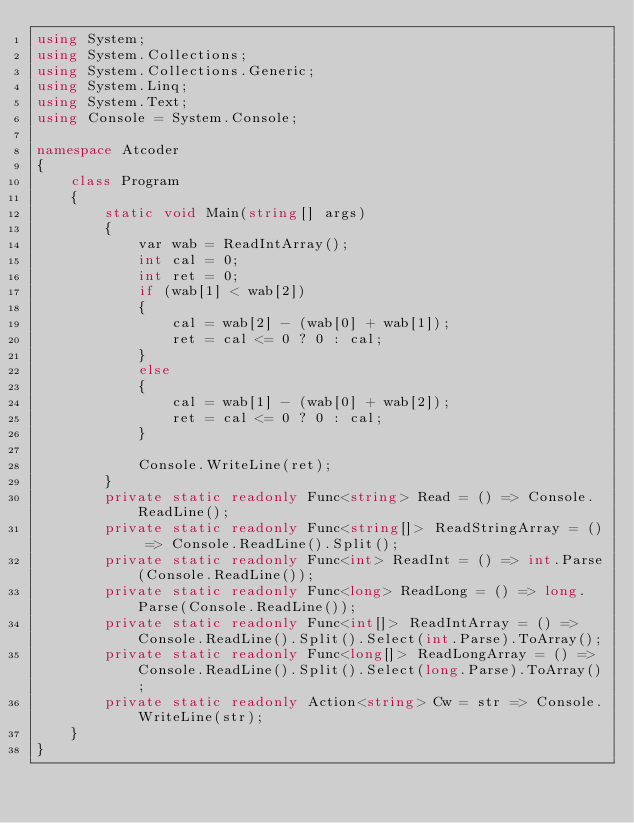<code> <loc_0><loc_0><loc_500><loc_500><_C#_>using System;
using System.Collections;
using System.Collections.Generic;
using System.Linq;
using System.Text;
using Console = System.Console;

namespace Atcoder
{
    class Program
    {
        static void Main(string[] args)
        {
            var wab = ReadIntArray();
            int cal = 0;
            int ret = 0;
            if (wab[1] < wab[2])
            {
                cal = wab[2] - (wab[0] + wab[1]);
                ret = cal <= 0 ? 0 : cal;
            }
            else
            {
                cal = wab[1] - (wab[0] + wab[2]);
                ret = cal <= 0 ? 0 : cal;
            }

            Console.WriteLine(ret);
        }
        private static readonly Func<string> Read = () => Console.ReadLine();
        private static readonly Func<string[]> ReadStringArray = () => Console.ReadLine().Split();
        private static readonly Func<int> ReadInt = () => int.Parse(Console.ReadLine());
        private static readonly Func<long> ReadLong = () => long.Parse(Console.ReadLine());
        private static readonly Func<int[]> ReadIntArray = () => Console.ReadLine().Split().Select(int.Parse).ToArray();
        private static readonly Func<long[]> ReadLongArray = () => Console.ReadLine().Split().Select(long.Parse).ToArray();
        private static readonly Action<string> Cw = str => Console.WriteLine(str);
    }
}</code> 